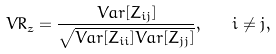Convert formula to latex. <formula><loc_0><loc_0><loc_500><loc_500>V R _ { z } = \frac { V a r [ Z _ { i j } ] } { \sqrt { V a r [ Z _ { i i } ] V a r [ Z _ { j j } ] } } , \quad i \neq j ,</formula> 